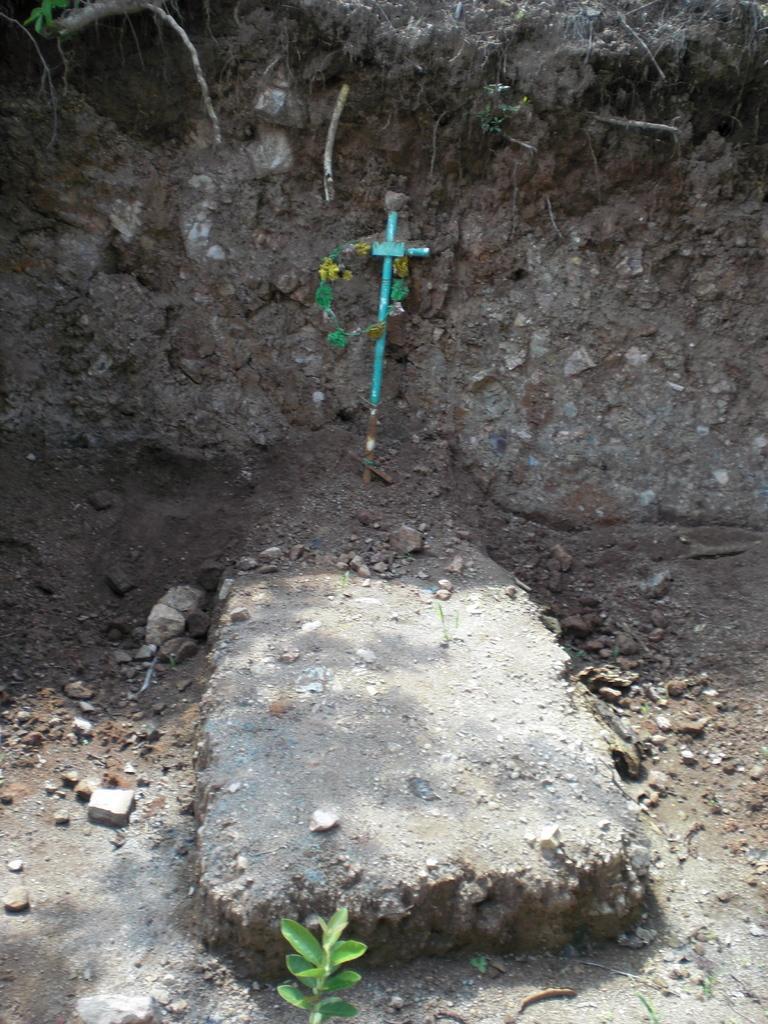Describe this image in one or two sentences. There is a grave, near a mud and a plant, which is having green color leaves. 